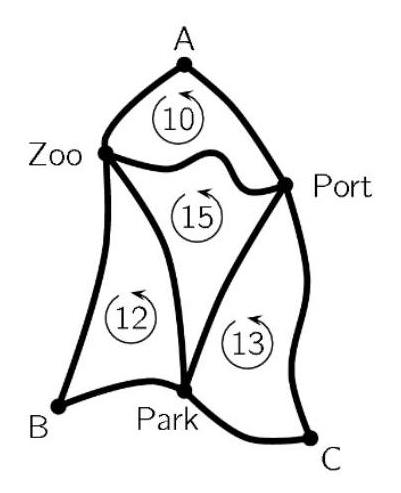Can you identify any mathematical concepts that can be derived or applied from the map's topology involving the locations A, B, and C? The map's topology and the given distances embody concepts of graph theory and circuit theory, particularly related to finding the shortest path or cycle in a weighted graph. The locations A, B, and C can be treated as vertices, and the distances (or paths connecting the attractions) as weighted edges. Techniques from graph theory like Dijkstra's algorithm or the Minimum Spanning Tree could be applied here to deduce the shortest possible route that connects all these points cyclically. 